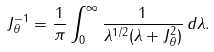Convert formula to latex. <formula><loc_0><loc_0><loc_500><loc_500>J _ { \theta } ^ { - 1 } = \frac { 1 } { \pi } \int _ { 0 } ^ { \infty } \frac { 1 } { \lambda ^ { 1 / 2 } ( \lambda + J _ { \theta } ^ { 2 } ) } \, d \lambda .</formula> 